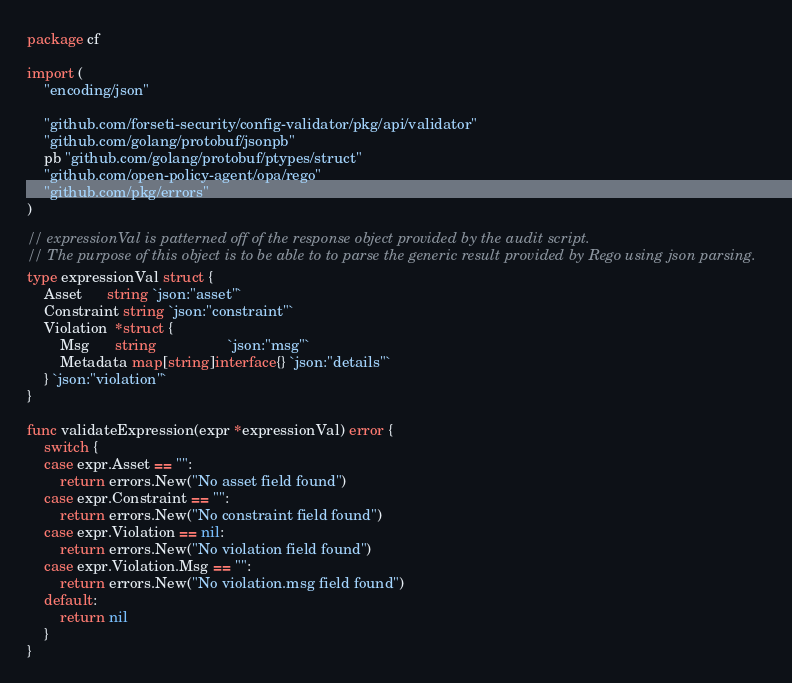<code> <loc_0><loc_0><loc_500><loc_500><_Go_>package cf

import (
	"encoding/json"

	"github.com/forseti-security/config-validator/pkg/api/validator"
	"github.com/golang/protobuf/jsonpb"
	pb "github.com/golang/protobuf/ptypes/struct"
	"github.com/open-policy-agent/opa/rego"
	"github.com/pkg/errors"
)

// expressionVal is patterned off of the response object provided by the audit script.
// The purpose of this object is to be able to to parse the generic result provided by Rego using json parsing.
type expressionVal struct {
	Asset      string `json:"asset"`
	Constraint string `json:"constraint"`
	Violation  *struct {
		Msg      string                 `json:"msg"`
		Metadata map[string]interface{} `json:"details"`
	} `json:"violation"`
}

func validateExpression(expr *expressionVal) error {
	switch {
	case expr.Asset == "":
		return errors.New("No asset field found")
	case expr.Constraint == "":
		return errors.New("No constraint field found")
	case expr.Violation == nil:
		return errors.New("No violation field found")
	case expr.Violation.Msg == "":
		return errors.New("No violation.msg field found")
	default:
		return nil
	}
}
</code> 